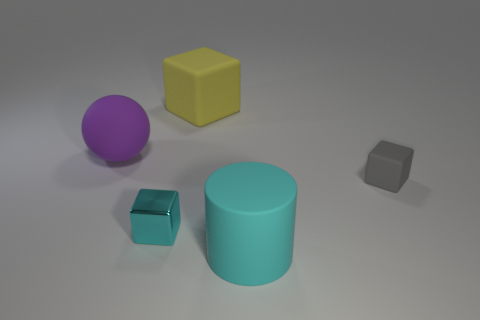Add 3 tiny gray objects. How many objects exist? 8 Subtract all cylinders. How many objects are left? 4 Subtract 0 brown cubes. How many objects are left? 5 Subtract all big blue matte objects. Subtract all big purple spheres. How many objects are left? 4 Add 2 matte cylinders. How many matte cylinders are left? 3 Add 4 large cyan metallic spheres. How many large cyan metallic spheres exist? 4 